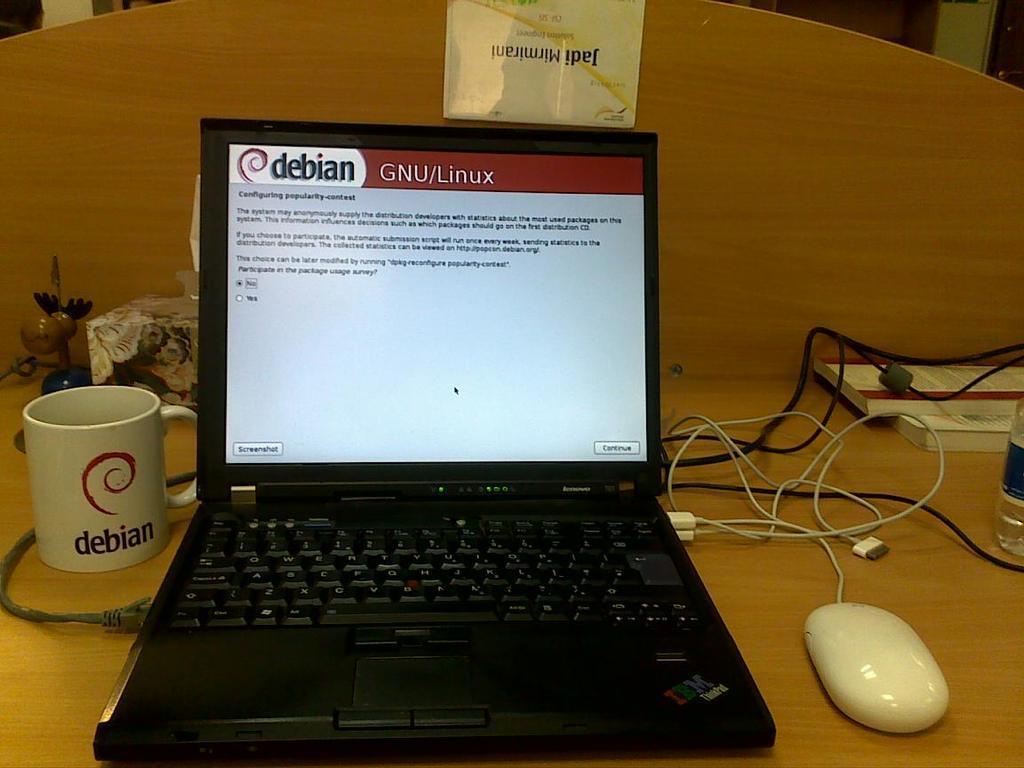Could you give a brief overview of what you see in this image? In this image we can see a laptop, mouse, cables, books, cup, water bottle and objects are on a platform and there is a small board on the wooden platform. In the background we can see objects. 